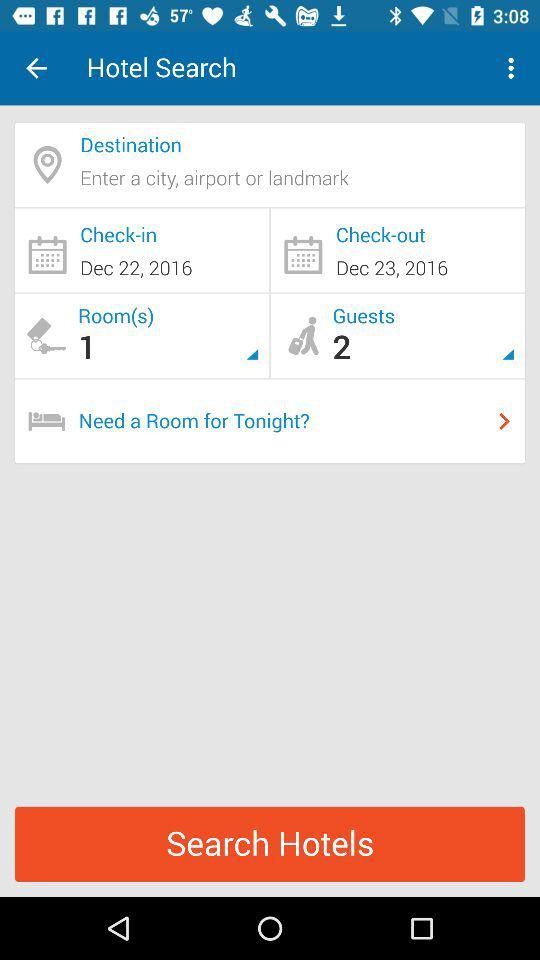How many more guests are there than rooms?
Answer the question using a single word or phrase. 1 